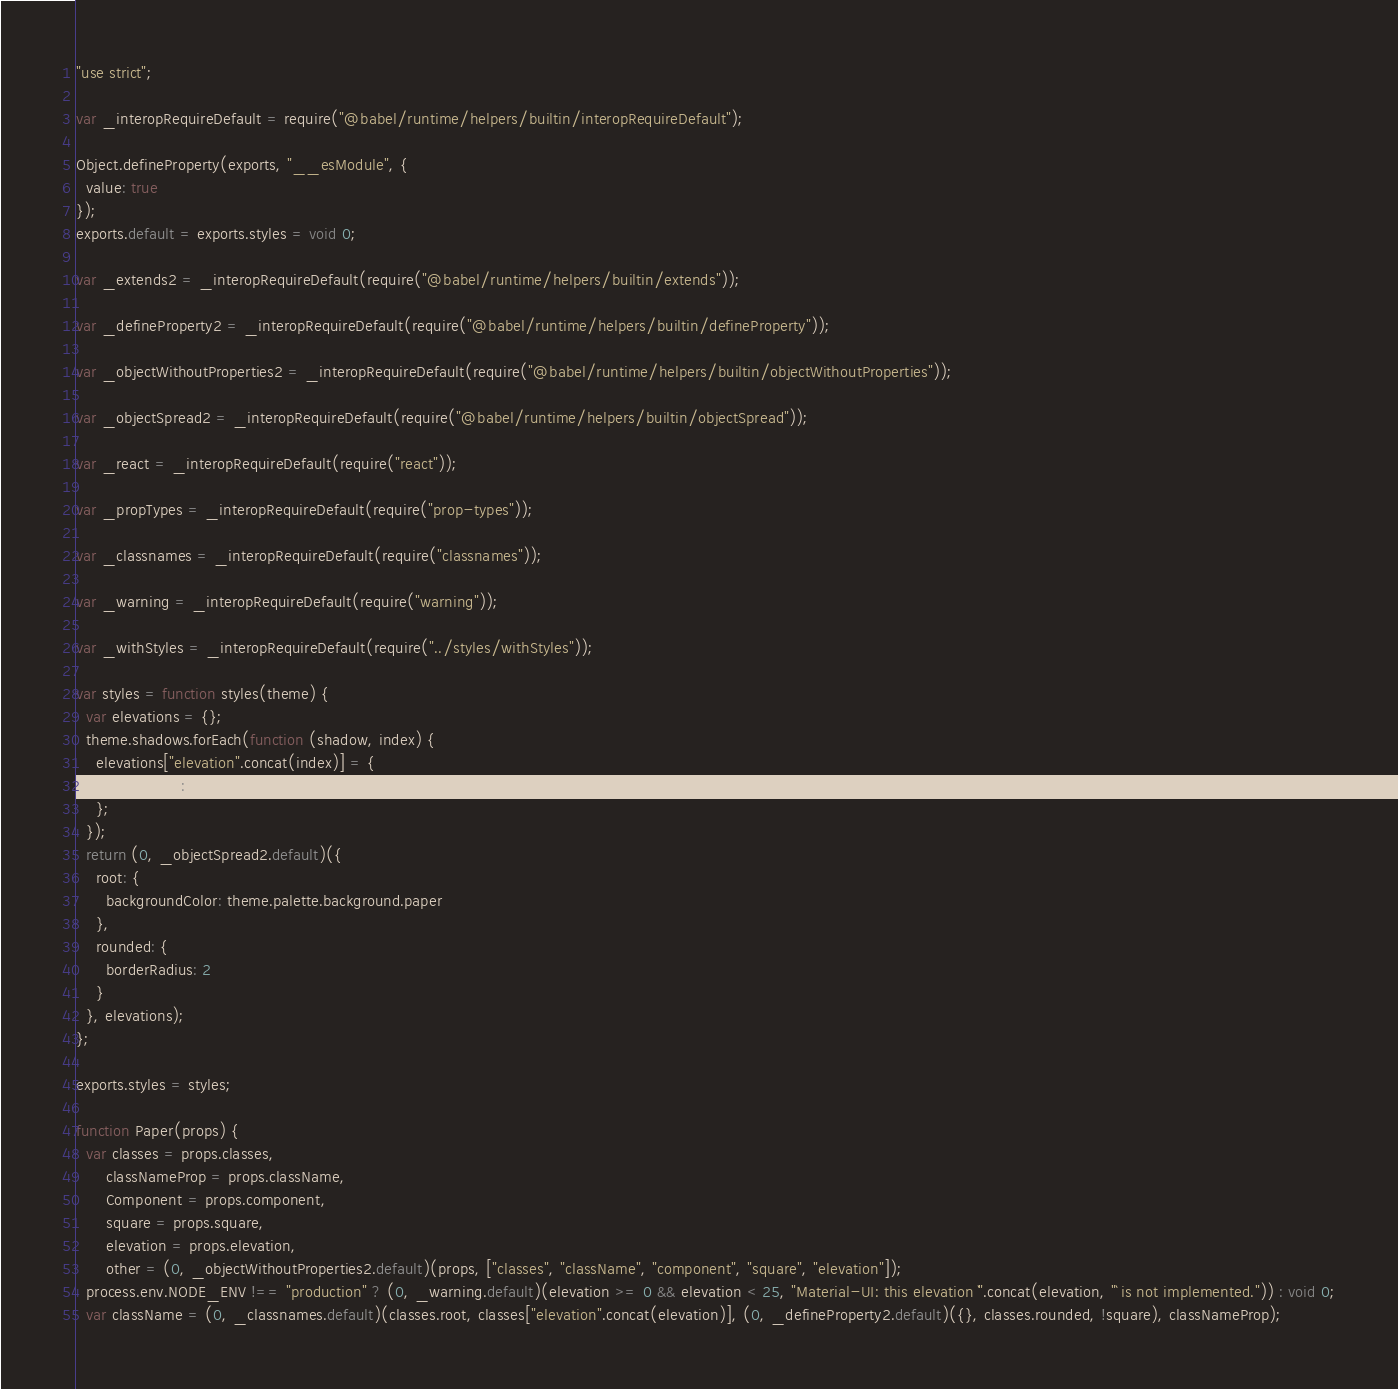<code> <loc_0><loc_0><loc_500><loc_500><_JavaScript_>"use strict";

var _interopRequireDefault = require("@babel/runtime/helpers/builtin/interopRequireDefault");

Object.defineProperty(exports, "__esModule", {
  value: true
});
exports.default = exports.styles = void 0;

var _extends2 = _interopRequireDefault(require("@babel/runtime/helpers/builtin/extends"));

var _defineProperty2 = _interopRequireDefault(require("@babel/runtime/helpers/builtin/defineProperty"));

var _objectWithoutProperties2 = _interopRequireDefault(require("@babel/runtime/helpers/builtin/objectWithoutProperties"));

var _objectSpread2 = _interopRequireDefault(require("@babel/runtime/helpers/builtin/objectSpread"));

var _react = _interopRequireDefault(require("react"));

var _propTypes = _interopRequireDefault(require("prop-types"));

var _classnames = _interopRequireDefault(require("classnames"));

var _warning = _interopRequireDefault(require("warning"));

var _withStyles = _interopRequireDefault(require("../styles/withStyles"));

var styles = function styles(theme) {
  var elevations = {};
  theme.shadows.forEach(function (shadow, index) {
    elevations["elevation".concat(index)] = {
      boxShadow: shadow
    };
  });
  return (0, _objectSpread2.default)({
    root: {
      backgroundColor: theme.palette.background.paper
    },
    rounded: {
      borderRadius: 2
    }
  }, elevations);
};

exports.styles = styles;

function Paper(props) {
  var classes = props.classes,
      classNameProp = props.className,
      Component = props.component,
      square = props.square,
      elevation = props.elevation,
      other = (0, _objectWithoutProperties2.default)(props, ["classes", "className", "component", "square", "elevation"]);
  process.env.NODE_ENV !== "production" ? (0, _warning.default)(elevation >= 0 && elevation < 25, "Material-UI: this elevation `".concat(elevation, "` is not implemented.")) : void 0;
  var className = (0, _classnames.default)(classes.root, classes["elevation".concat(elevation)], (0, _defineProperty2.default)({}, classes.rounded, !square), classNameProp);</code> 